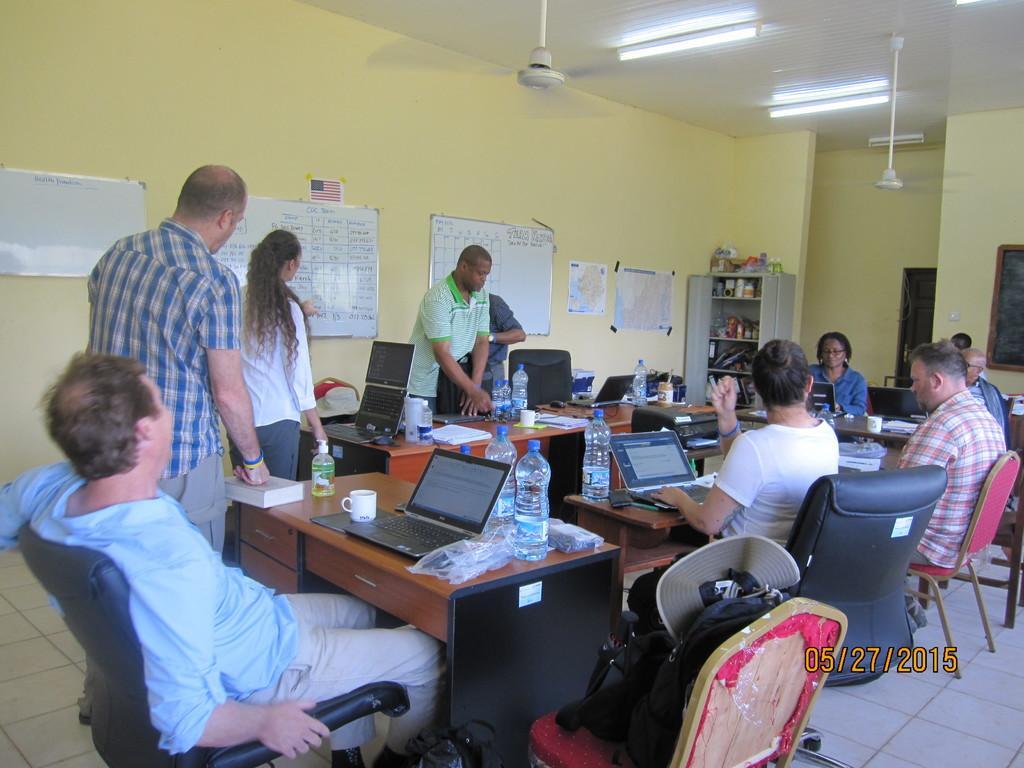In one or two sentences, can you explain what this image depicts? There are many people sitting and some are standing. A person wearing a blue shirt is sitting on a chair. In front of him there is a table. On the table there is a cup, laptop , bottles and a book. There is bag on a chair. In the background there is a wall. On the wall there are boards, notices. In the corner there is a cupboard. Inside cupboard there are books and many other items. In the ceiling there are tube lights and fans. 